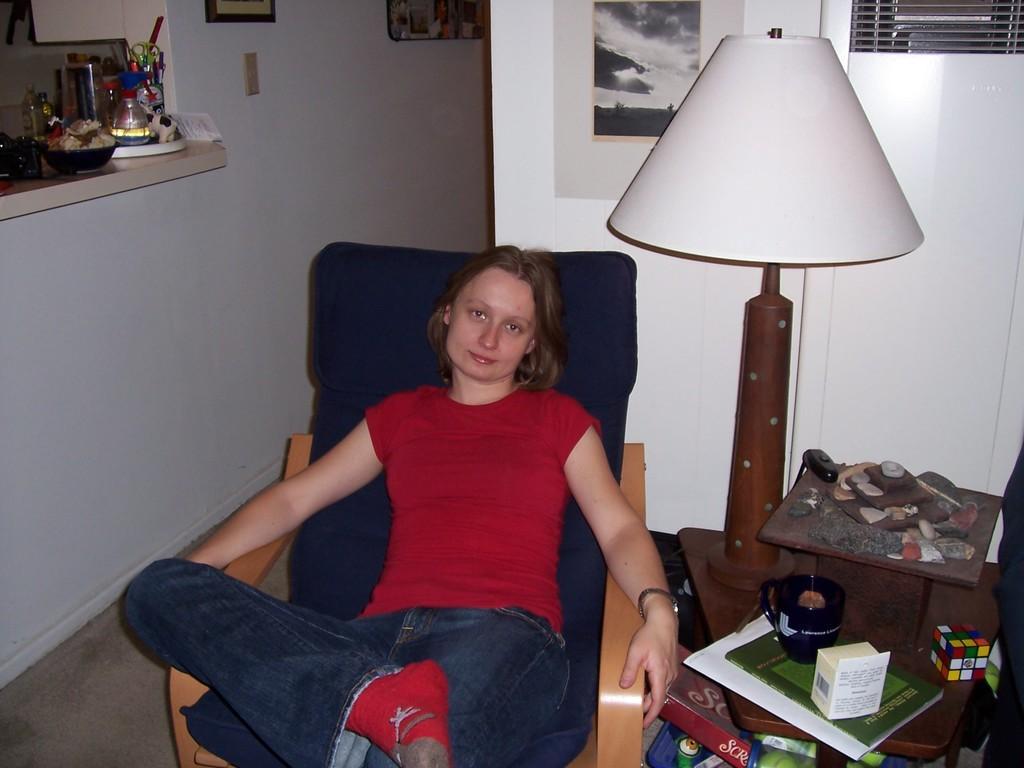Could you give a brief overview of what you see in this image? This picture shows a woman and we see a light and papers and toy on the table 